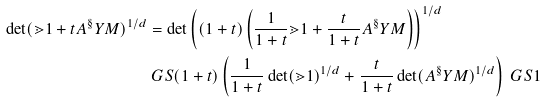<formula> <loc_0><loc_0><loc_500><loc_500>\det ( \mathbb { m } { 1 } + t A ^ { \S } Y M ) ^ { 1 / d } & = \det \left ( ( 1 + t ) \left ( \frac { 1 } { 1 + t } \mathbb { m } { 1 } + \frac { t } { 1 + t } A ^ { \S } Y M \right ) \right ) ^ { 1 / d } \\ & \ G S ( 1 + t ) \left ( \frac { 1 } { 1 + t } \det ( \mathbb { m } { 1 } ) ^ { 1 / d } + \frac { t } { 1 + t } \det ( A ^ { \S } Y M ) ^ { 1 / d } \right ) \ G S 1</formula> 